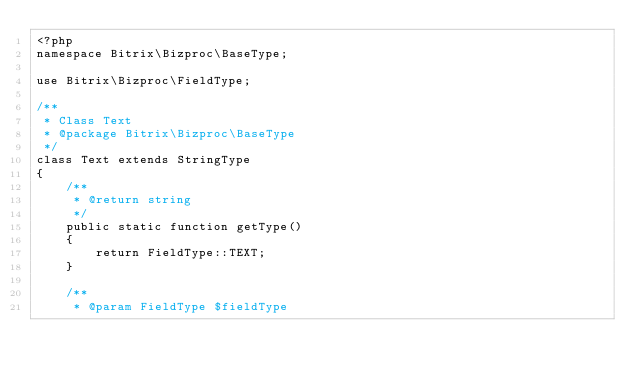<code> <loc_0><loc_0><loc_500><loc_500><_PHP_><?php
namespace Bitrix\Bizproc\BaseType;

use Bitrix\Bizproc\FieldType;

/**
 * Class Text
 * @package Bitrix\Bizproc\BaseType
 */
class Text extends StringType
{
	/**
	 * @return string
	 */
	public static function getType()
	{
		return FieldType::TEXT;
	}

	/**
	 * @param FieldType $fieldType</code> 